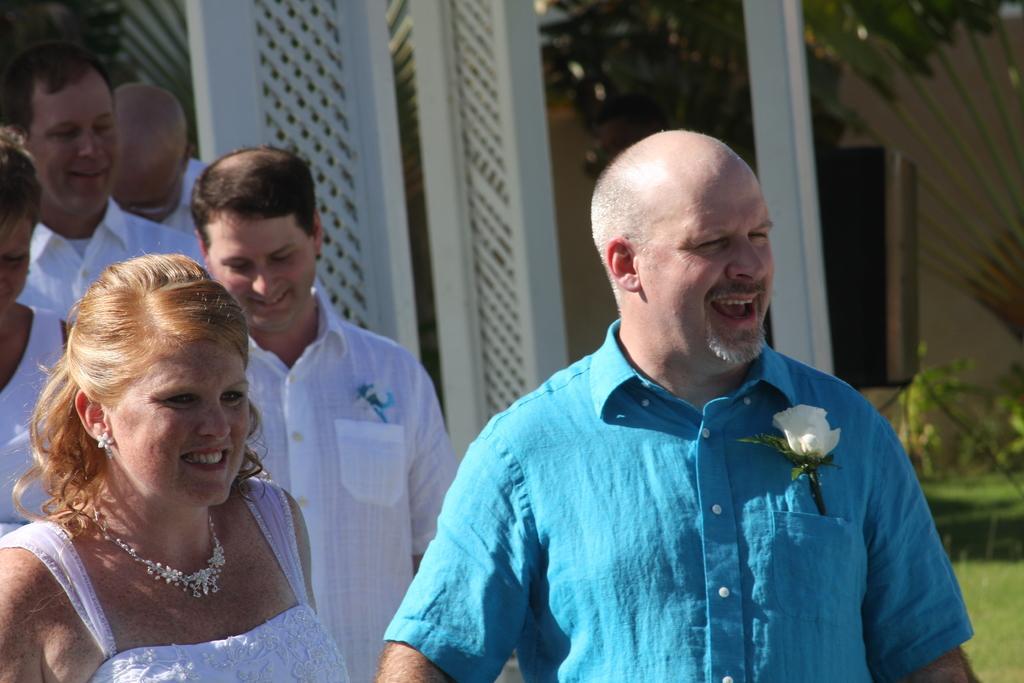Describe this image in one or two sentences. In front of the picture, we see a man in blue shirt and the woman in white dress are standing. Both of them are smiling. We see a white rose in his shirt pocket. Behind them, we see four people who are wearing white shirts are standing. They are smiling. Behind them, we see a building in white color. We even see a pole, plants and a tree. In the right bottom of the picture, we see the grass. 